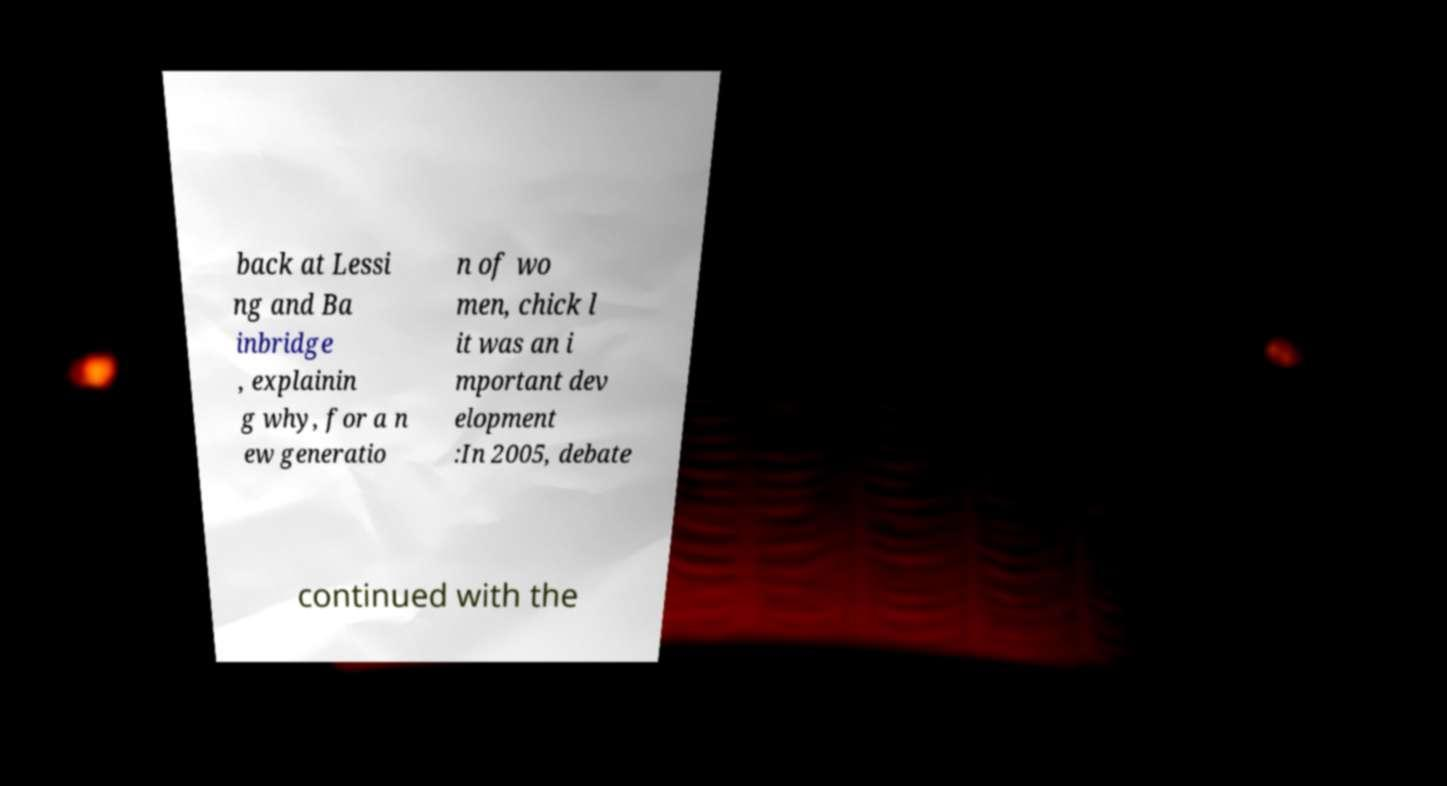There's text embedded in this image that I need extracted. Can you transcribe it verbatim? back at Lessi ng and Ba inbridge , explainin g why, for a n ew generatio n of wo men, chick l it was an i mportant dev elopment :In 2005, debate continued with the 